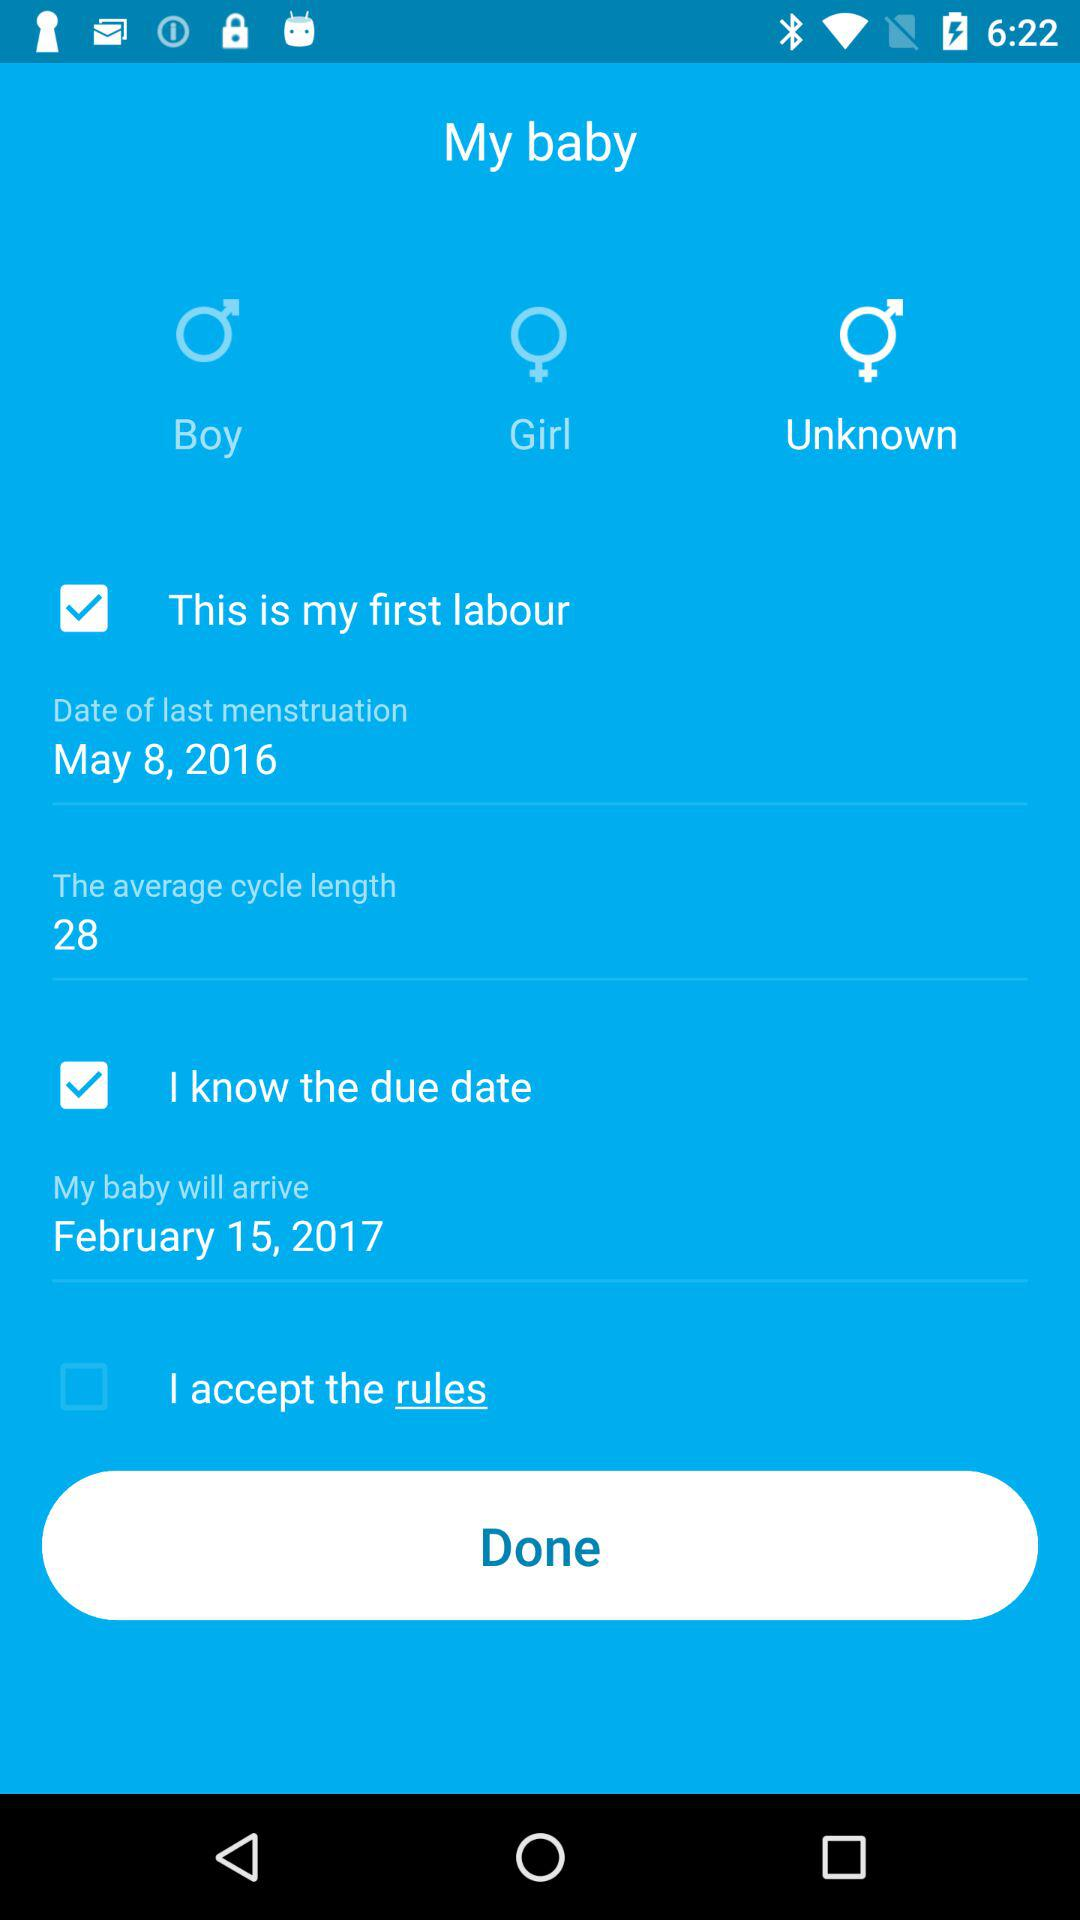What is the average cycle length? The average cycle length is 28. 